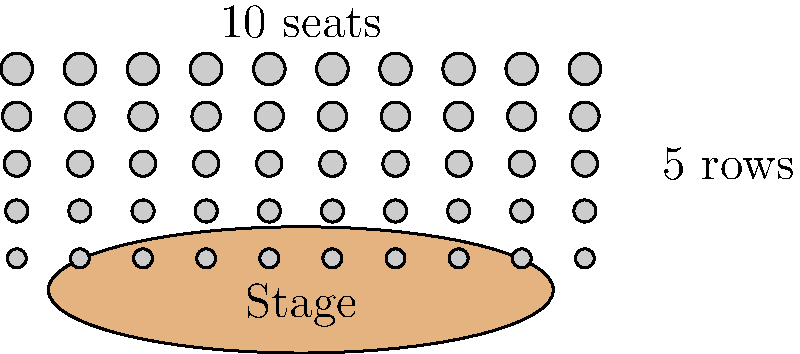As a retired music teacher organizing a community concert, you're estimating the audience capacity. The auditorium has a seating arrangement as shown above, with 5 rows and 10 seats per row. If you decide to add 2 more rows with the same number of seats, and increase the number of seats in each row by 4, what would be the total seating capacity of the auditorium? Let's approach this step-by-step:

1. Current seating arrangement:
   - Number of rows: 5
   - Seats per row: 10
   - Total seats: $5 \times 10 = 50$

2. New arrangement:
   - Number of rows: $5 + 2 = 7$ (adding 2 more rows)
   - Seats per row: $10 + 4 = 14$ (increasing by 4 seats per row)

3. Calculate the new total seating capacity:
   - New total seats: $7 \times 14 = 98$

Therefore, after the modifications, the auditorium will have a total seating capacity of 98.
Answer: 98 seats 